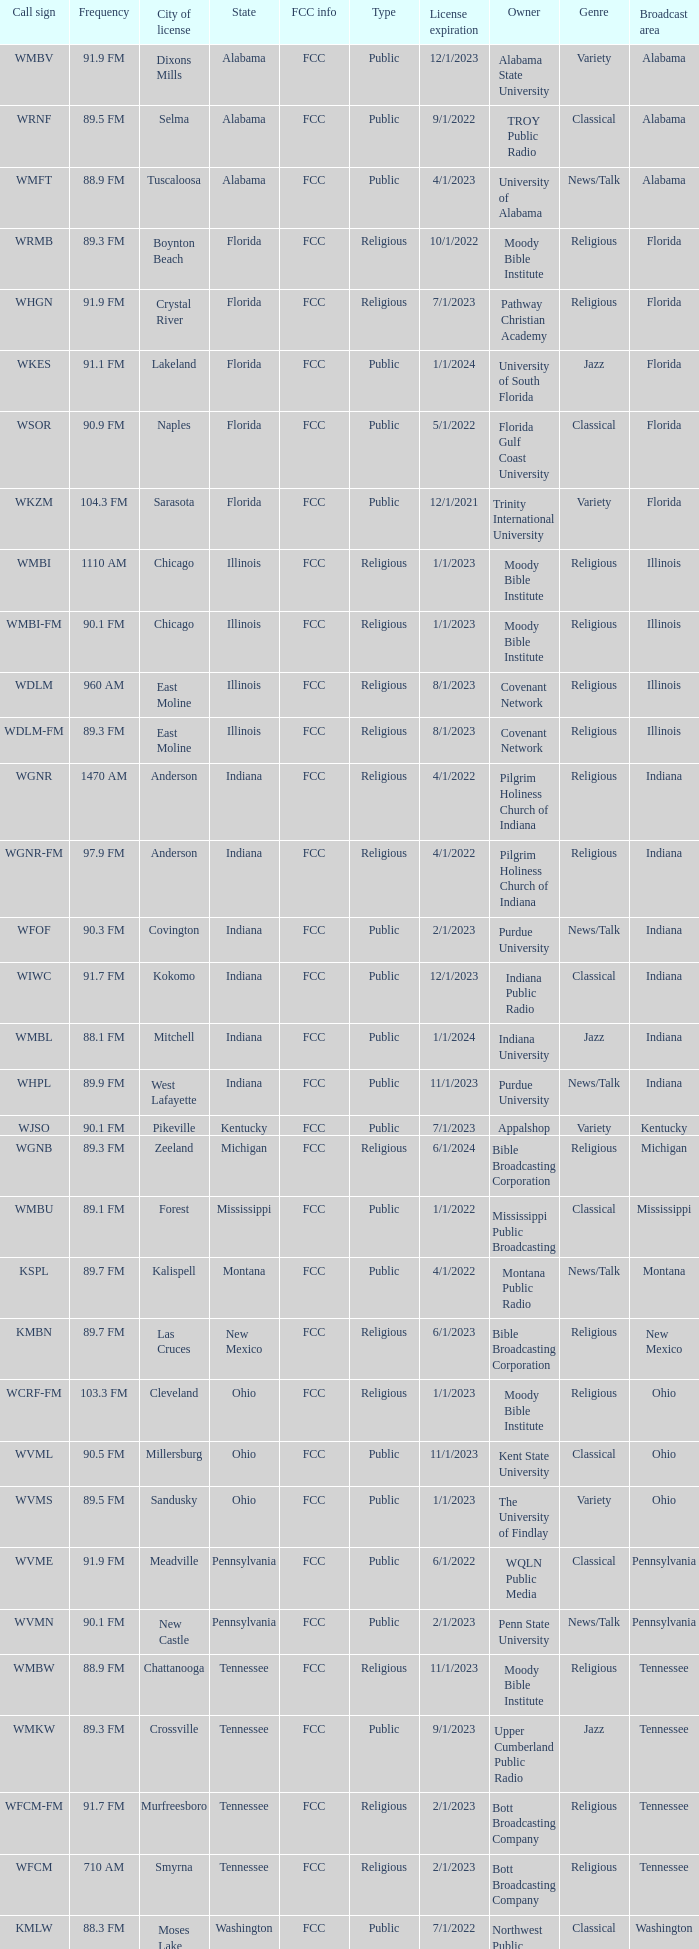What is the frequency of the radio station with a call sign of WGNR-FM? 97.9 FM. 